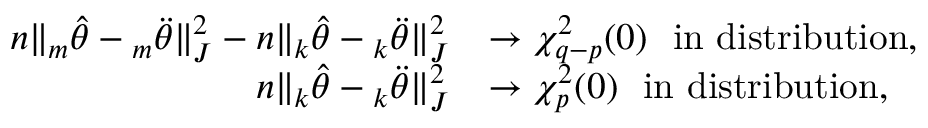<formula> <loc_0><loc_0><loc_500><loc_500>\begin{array} { r l } { n \| { _ { m } \hat { \theta } } - { _ { m } \ddot { \theta } } \| _ { J } ^ { 2 } - n \| { _ { k } \hat { \theta } } - { _ { k } \ddot { \theta } } \| _ { J } ^ { 2 } } & { \rightarrow \chi _ { q - p } ^ { 2 } ( 0 ) i n d i s t r i b u t i o n , } \\ { n \| { _ { k } \hat { \theta } } - { _ { k } \ddot { \theta } } \| _ { J } ^ { 2 } } & { \rightarrow \chi _ { p } ^ { 2 } ( 0 ) i n d i s t r i b u t i o n , } \end{array}</formula> 